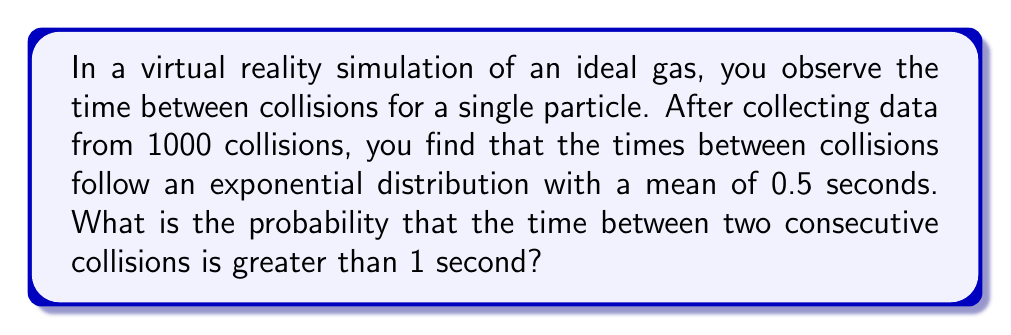Give your solution to this math problem. To solve this problem, we need to use the properties of the exponential distribution, which is commonly used to model the time between events in a Poisson process, such as collisions in an ideal gas.

1) The probability density function (PDF) of an exponential distribution is given by:

   $$f(x) = \lambda e^{-\lambda x}$$

   where $\lambda$ is the rate parameter.

2) The mean of an exponential distribution is $\frac{1}{\lambda}$. We're given that the mean is 0.5 seconds, so:

   $$0.5 = \frac{1}{\lambda}$$
   $$\lambda = 2$$

3) We want to find $P(X > 1)$, where $X$ is the time between collisions. For an exponential distribution, this is given by:

   $$P(X > x) = e^{-\lambda x}$$

4) Substituting our values:

   $$P(X > 1) = e^{-2 \cdot 1} = e^{-2}$$

5) We can calculate this value:

   $$e^{-2} \approx 0.1353$$

Thus, the probability that the time between two consecutive collisions is greater than 1 second is approximately 0.1353 or about 13.53%.
Answer: $e^{-2} \approx 0.1353$ or approximately 13.53% 